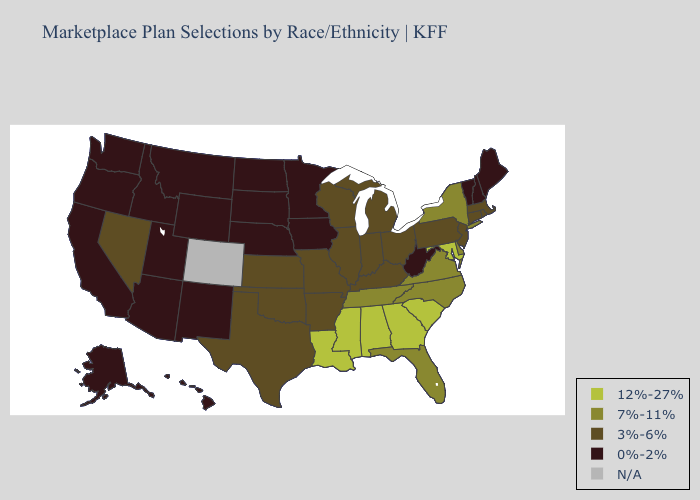Name the states that have a value in the range 12%-27%?
Write a very short answer. Alabama, Georgia, Louisiana, Maryland, Mississippi, South Carolina. Among the states that border Georgia , which have the highest value?
Be succinct. Alabama, South Carolina. What is the lowest value in states that border Oklahoma?
Answer briefly. 0%-2%. Name the states that have a value in the range N/A?
Give a very brief answer. Colorado. Does Delaware have the lowest value in the South?
Short answer required. No. What is the value of Mississippi?
Write a very short answer. 12%-27%. What is the value of Texas?
Concise answer only. 3%-6%. What is the highest value in the West ?
Answer briefly. 3%-6%. Name the states that have a value in the range 0%-2%?
Concise answer only. Alaska, Arizona, California, Hawaii, Idaho, Iowa, Maine, Minnesota, Montana, Nebraska, New Hampshire, New Mexico, North Dakota, Oregon, South Dakota, Utah, Vermont, Washington, West Virginia, Wyoming. Name the states that have a value in the range 0%-2%?
Short answer required. Alaska, Arizona, California, Hawaii, Idaho, Iowa, Maine, Minnesota, Montana, Nebraska, New Hampshire, New Mexico, North Dakota, Oregon, South Dakota, Utah, Vermont, Washington, West Virginia, Wyoming. Does the first symbol in the legend represent the smallest category?
Give a very brief answer. No. What is the value of Michigan?
Quick response, please. 3%-6%. Among the states that border North Dakota , which have the highest value?
Concise answer only. Minnesota, Montana, South Dakota. Which states have the lowest value in the USA?
Answer briefly. Alaska, Arizona, California, Hawaii, Idaho, Iowa, Maine, Minnesota, Montana, Nebraska, New Hampshire, New Mexico, North Dakota, Oregon, South Dakota, Utah, Vermont, Washington, West Virginia, Wyoming. Name the states that have a value in the range 0%-2%?
Write a very short answer. Alaska, Arizona, California, Hawaii, Idaho, Iowa, Maine, Minnesota, Montana, Nebraska, New Hampshire, New Mexico, North Dakota, Oregon, South Dakota, Utah, Vermont, Washington, West Virginia, Wyoming. 